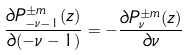<formula> <loc_0><loc_0><loc_500><loc_500>\frac { \partial P _ { - \nu - 1 } ^ { \pm m } ( z ) } { \partial ( - \nu - 1 ) } = - \frac { \partial P _ { \nu } ^ { \pm m } ( z ) } { \partial \nu }</formula> 